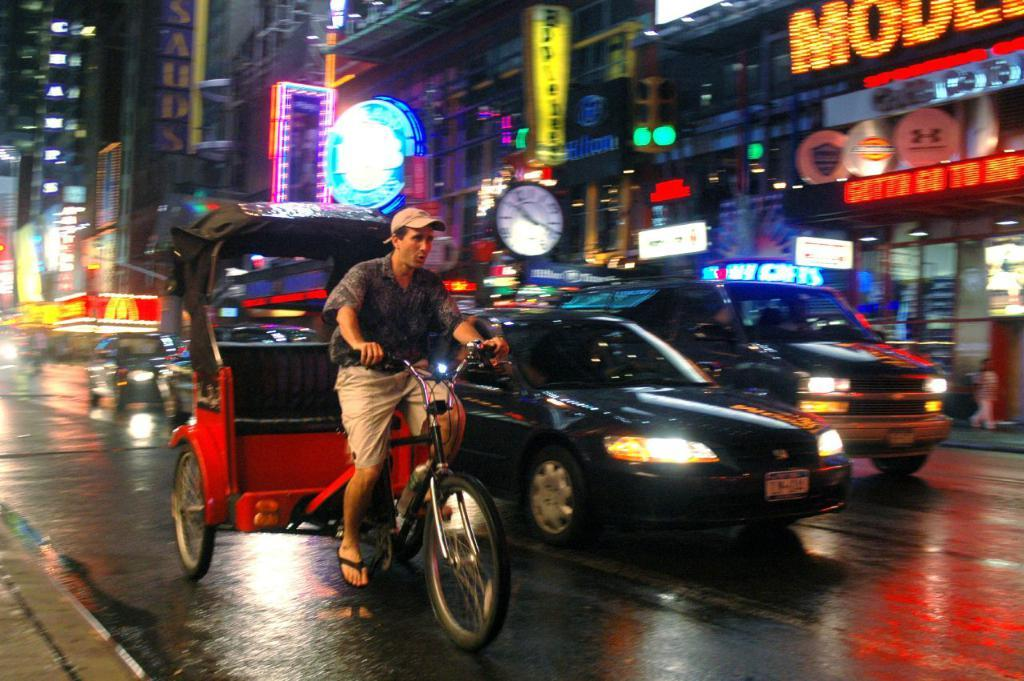<image>
Summarize the visual content of the image. A man driving a bicycle cab drives next to a car with New York license plates. 